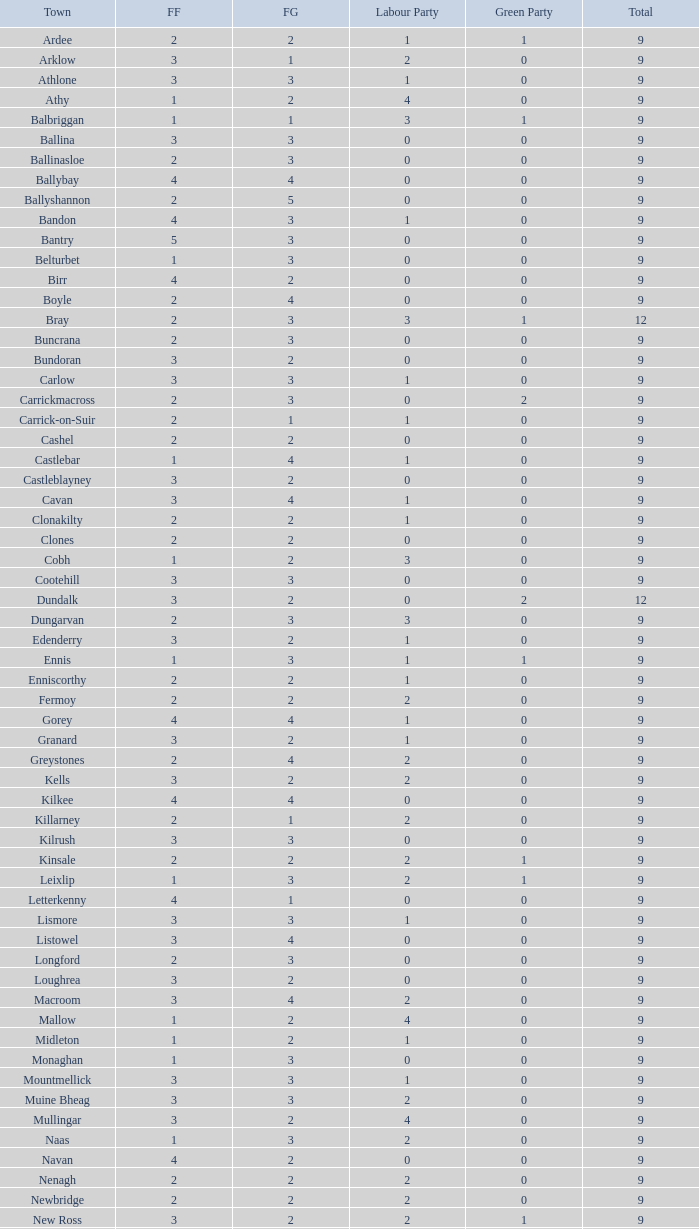What is the lowest number in the Labour Party for the Fianna Fail higher than 5? None. 